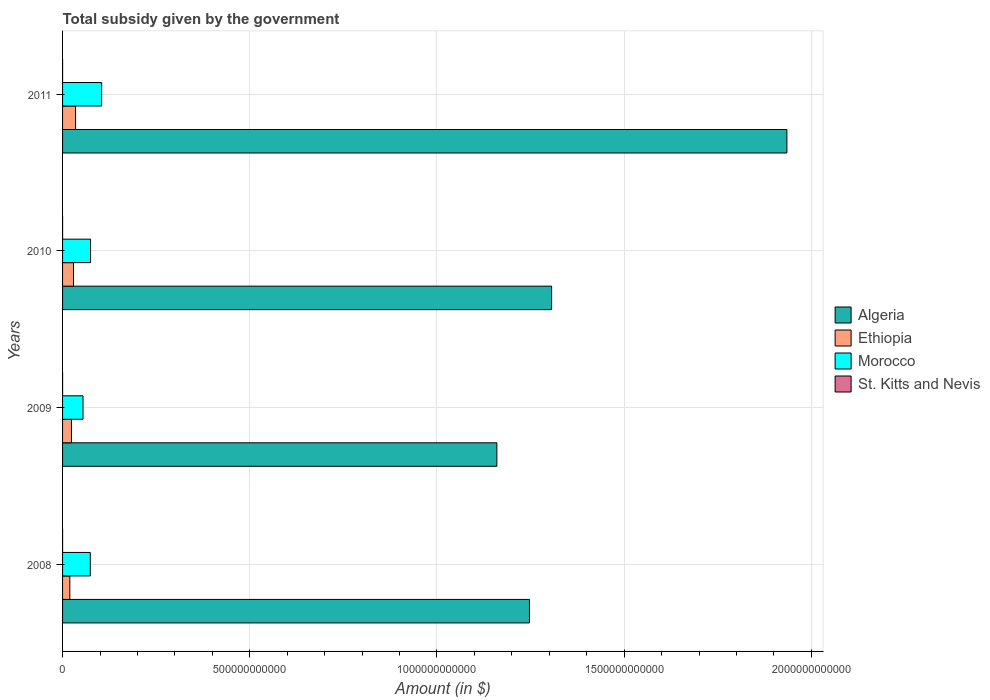How many bars are there on the 2nd tick from the top?
Offer a very short reply. 4. How many bars are there on the 2nd tick from the bottom?
Ensure brevity in your answer.  4. What is the label of the 3rd group of bars from the top?
Ensure brevity in your answer.  2009. In how many cases, is the number of bars for a given year not equal to the number of legend labels?
Make the answer very short. 0. What is the total revenue collected by the government in Ethiopia in 2009?
Keep it short and to the point. 2.37e+1. Across all years, what is the maximum total revenue collected by the government in St. Kitts and Nevis?
Your answer should be compact. 7.11e+07. Across all years, what is the minimum total revenue collected by the government in Algeria?
Give a very brief answer. 1.16e+12. In which year was the total revenue collected by the government in St. Kitts and Nevis minimum?
Your answer should be compact. 2010. What is the total total revenue collected by the government in St. Kitts and Nevis in the graph?
Keep it short and to the point. 2.46e+08. What is the difference between the total revenue collected by the government in St. Kitts and Nevis in 2008 and that in 2011?
Give a very brief answer. -1.25e+07. What is the difference between the total revenue collected by the government in Morocco in 2010 and the total revenue collected by the government in St. Kitts and Nevis in 2011?
Your answer should be very brief. 7.48e+1. What is the average total revenue collected by the government in St. Kitts and Nevis per year?
Offer a terse response. 6.16e+07. In the year 2008, what is the difference between the total revenue collected by the government in Morocco and total revenue collected by the government in Algeria?
Provide a succinct answer. -1.17e+12. In how many years, is the total revenue collected by the government in St. Kitts and Nevis greater than 500000000000 $?
Your answer should be compact. 0. What is the ratio of the total revenue collected by the government in St. Kitts and Nevis in 2009 to that in 2010?
Offer a very short reply. 1.03. Is the total revenue collected by the government in St. Kitts and Nevis in 2008 less than that in 2010?
Your answer should be compact. No. What is the difference between the highest and the second highest total revenue collected by the government in St. Kitts and Nevis?
Your answer should be very brief. 1.20e+07. What is the difference between the highest and the lowest total revenue collected by the government in Ethiopia?
Give a very brief answer. 1.53e+1. What does the 2nd bar from the top in 2010 represents?
Your response must be concise. Morocco. What does the 2nd bar from the bottom in 2010 represents?
Ensure brevity in your answer.  Ethiopia. Is it the case that in every year, the sum of the total revenue collected by the government in St. Kitts and Nevis and total revenue collected by the government in Algeria is greater than the total revenue collected by the government in Ethiopia?
Offer a terse response. Yes. How many years are there in the graph?
Offer a terse response. 4. What is the difference between two consecutive major ticks on the X-axis?
Your response must be concise. 5.00e+11. Are the values on the major ticks of X-axis written in scientific E-notation?
Your response must be concise. No. Does the graph contain any zero values?
Make the answer very short. No. How are the legend labels stacked?
Your answer should be very brief. Vertical. What is the title of the graph?
Your answer should be very brief. Total subsidy given by the government. Does "Vietnam" appear as one of the legend labels in the graph?
Ensure brevity in your answer.  No. What is the label or title of the X-axis?
Offer a terse response. Amount (in $). What is the label or title of the Y-axis?
Keep it short and to the point. Years. What is the Amount (in $) in Algeria in 2008?
Ensure brevity in your answer.  1.25e+12. What is the Amount (in $) of Ethiopia in 2008?
Your response must be concise. 1.94e+1. What is the Amount (in $) of Morocco in 2008?
Your response must be concise. 7.41e+1. What is the Amount (in $) of St. Kitts and Nevis in 2008?
Offer a terse response. 5.86e+07. What is the Amount (in $) of Algeria in 2009?
Your answer should be compact. 1.16e+12. What is the Amount (in $) in Ethiopia in 2009?
Offer a very short reply. 2.37e+1. What is the Amount (in $) of Morocco in 2009?
Provide a succinct answer. 5.46e+1. What is the Amount (in $) in St. Kitts and Nevis in 2009?
Your response must be concise. 5.91e+07. What is the Amount (in $) of Algeria in 2010?
Provide a short and direct response. 1.31e+12. What is the Amount (in $) in Ethiopia in 2010?
Your response must be concise. 2.92e+1. What is the Amount (in $) of Morocco in 2010?
Ensure brevity in your answer.  7.48e+1. What is the Amount (in $) of St. Kitts and Nevis in 2010?
Provide a succinct answer. 5.76e+07. What is the Amount (in $) of Algeria in 2011?
Provide a succinct answer. 1.93e+12. What is the Amount (in $) in Ethiopia in 2011?
Provide a succinct answer. 3.47e+1. What is the Amount (in $) of Morocco in 2011?
Your answer should be very brief. 1.04e+11. What is the Amount (in $) in St. Kitts and Nevis in 2011?
Your answer should be compact. 7.11e+07. Across all years, what is the maximum Amount (in $) in Algeria?
Offer a very short reply. 1.93e+12. Across all years, what is the maximum Amount (in $) in Ethiopia?
Offer a very short reply. 3.47e+1. Across all years, what is the maximum Amount (in $) in Morocco?
Offer a very short reply. 1.04e+11. Across all years, what is the maximum Amount (in $) of St. Kitts and Nevis?
Offer a very short reply. 7.11e+07. Across all years, what is the minimum Amount (in $) of Algeria?
Offer a terse response. 1.16e+12. Across all years, what is the minimum Amount (in $) of Ethiopia?
Give a very brief answer. 1.94e+1. Across all years, what is the minimum Amount (in $) in Morocco?
Provide a succinct answer. 5.46e+1. Across all years, what is the minimum Amount (in $) of St. Kitts and Nevis?
Your answer should be very brief. 5.76e+07. What is the total Amount (in $) in Algeria in the graph?
Make the answer very short. 5.65e+12. What is the total Amount (in $) of Ethiopia in the graph?
Keep it short and to the point. 1.07e+11. What is the total Amount (in $) in Morocco in the graph?
Make the answer very short. 3.08e+11. What is the total Amount (in $) of St. Kitts and Nevis in the graph?
Give a very brief answer. 2.46e+08. What is the difference between the Amount (in $) of Algeria in 2008 and that in 2009?
Make the answer very short. 8.71e+1. What is the difference between the Amount (in $) of Ethiopia in 2008 and that in 2009?
Your answer should be very brief. -4.33e+09. What is the difference between the Amount (in $) of Morocco in 2008 and that in 2009?
Offer a very short reply. 1.95e+1. What is the difference between the Amount (in $) of St. Kitts and Nevis in 2008 and that in 2009?
Offer a very short reply. -5.00e+05. What is the difference between the Amount (in $) in Algeria in 2008 and that in 2010?
Your response must be concise. -5.92e+1. What is the difference between the Amount (in $) of Ethiopia in 2008 and that in 2010?
Give a very brief answer. -9.79e+09. What is the difference between the Amount (in $) of Morocco in 2008 and that in 2010?
Make the answer very short. -7.28e+08. What is the difference between the Amount (in $) of St. Kitts and Nevis in 2008 and that in 2010?
Offer a terse response. 1.00e+06. What is the difference between the Amount (in $) in Algeria in 2008 and that in 2011?
Offer a terse response. -6.88e+11. What is the difference between the Amount (in $) in Ethiopia in 2008 and that in 2011?
Keep it short and to the point. -1.53e+1. What is the difference between the Amount (in $) in Morocco in 2008 and that in 2011?
Keep it short and to the point. -3.03e+1. What is the difference between the Amount (in $) in St. Kitts and Nevis in 2008 and that in 2011?
Your answer should be compact. -1.25e+07. What is the difference between the Amount (in $) in Algeria in 2009 and that in 2010?
Your response must be concise. -1.46e+11. What is the difference between the Amount (in $) in Ethiopia in 2009 and that in 2010?
Give a very brief answer. -5.47e+09. What is the difference between the Amount (in $) in Morocco in 2009 and that in 2010?
Your answer should be compact. -2.02e+1. What is the difference between the Amount (in $) in St. Kitts and Nevis in 2009 and that in 2010?
Offer a very short reply. 1.50e+06. What is the difference between the Amount (in $) in Algeria in 2009 and that in 2011?
Provide a short and direct response. -7.75e+11. What is the difference between the Amount (in $) of Ethiopia in 2009 and that in 2011?
Your answer should be compact. -1.10e+1. What is the difference between the Amount (in $) in Morocco in 2009 and that in 2011?
Your answer should be compact. -4.98e+1. What is the difference between the Amount (in $) in St. Kitts and Nevis in 2009 and that in 2011?
Your answer should be very brief. -1.20e+07. What is the difference between the Amount (in $) of Algeria in 2010 and that in 2011?
Offer a very short reply. -6.28e+11. What is the difference between the Amount (in $) in Ethiopia in 2010 and that in 2011?
Offer a very short reply. -5.52e+09. What is the difference between the Amount (in $) of Morocco in 2010 and that in 2011?
Your answer should be very brief. -2.96e+1. What is the difference between the Amount (in $) of St. Kitts and Nevis in 2010 and that in 2011?
Your response must be concise. -1.35e+07. What is the difference between the Amount (in $) in Algeria in 2008 and the Amount (in $) in Ethiopia in 2009?
Your answer should be compact. 1.22e+12. What is the difference between the Amount (in $) in Algeria in 2008 and the Amount (in $) in Morocco in 2009?
Ensure brevity in your answer.  1.19e+12. What is the difference between the Amount (in $) in Algeria in 2008 and the Amount (in $) in St. Kitts and Nevis in 2009?
Offer a terse response. 1.25e+12. What is the difference between the Amount (in $) of Ethiopia in 2008 and the Amount (in $) of Morocco in 2009?
Offer a terse response. -3.52e+1. What is the difference between the Amount (in $) of Ethiopia in 2008 and the Amount (in $) of St. Kitts and Nevis in 2009?
Offer a terse response. 1.93e+1. What is the difference between the Amount (in $) in Morocco in 2008 and the Amount (in $) in St. Kitts and Nevis in 2009?
Your answer should be compact. 7.41e+1. What is the difference between the Amount (in $) in Algeria in 2008 and the Amount (in $) in Ethiopia in 2010?
Keep it short and to the point. 1.22e+12. What is the difference between the Amount (in $) in Algeria in 2008 and the Amount (in $) in Morocco in 2010?
Make the answer very short. 1.17e+12. What is the difference between the Amount (in $) of Algeria in 2008 and the Amount (in $) of St. Kitts and Nevis in 2010?
Offer a terse response. 1.25e+12. What is the difference between the Amount (in $) of Ethiopia in 2008 and the Amount (in $) of Morocco in 2010?
Give a very brief answer. -5.54e+1. What is the difference between the Amount (in $) in Ethiopia in 2008 and the Amount (in $) in St. Kitts and Nevis in 2010?
Offer a very short reply. 1.93e+1. What is the difference between the Amount (in $) of Morocco in 2008 and the Amount (in $) of St. Kitts and Nevis in 2010?
Your response must be concise. 7.41e+1. What is the difference between the Amount (in $) in Algeria in 2008 and the Amount (in $) in Ethiopia in 2011?
Keep it short and to the point. 1.21e+12. What is the difference between the Amount (in $) in Algeria in 2008 and the Amount (in $) in Morocco in 2011?
Ensure brevity in your answer.  1.14e+12. What is the difference between the Amount (in $) of Algeria in 2008 and the Amount (in $) of St. Kitts and Nevis in 2011?
Keep it short and to the point. 1.25e+12. What is the difference between the Amount (in $) in Ethiopia in 2008 and the Amount (in $) in Morocco in 2011?
Offer a terse response. -8.51e+1. What is the difference between the Amount (in $) of Ethiopia in 2008 and the Amount (in $) of St. Kitts and Nevis in 2011?
Keep it short and to the point. 1.93e+1. What is the difference between the Amount (in $) in Morocco in 2008 and the Amount (in $) in St. Kitts and Nevis in 2011?
Provide a short and direct response. 7.40e+1. What is the difference between the Amount (in $) in Algeria in 2009 and the Amount (in $) in Ethiopia in 2010?
Your response must be concise. 1.13e+12. What is the difference between the Amount (in $) of Algeria in 2009 and the Amount (in $) of Morocco in 2010?
Keep it short and to the point. 1.09e+12. What is the difference between the Amount (in $) of Algeria in 2009 and the Amount (in $) of St. Kitts and Nevis in 2010?
Provide a succinct answer. 1.16e+12. What is the difference between the Amount (in $) of Ethiopia in 2009 and the Amount (in $) of Morocco in 2010?
Give a very brief answer. -5.11e+1. What is the difference between the Amount (in $) in Ethiopia in 2009 and the Amount (in $) in St. Kitts and Nevis in 2010?
Give a very brief answer. 2.37e+1. What is the difference between the Amount (in $) in Morocco in 2009 and the Amount (in $) in St. Kitts and Nevis in 2010?
Your answer should be compact. 5.46e+1. What is the difference between the Amount (in $) in Algeria in 2009 and the Amount (in $) in Ethiopia in 2011?
Your answer should be very brief. 1.13e+12. What is the difference between the Amount (in $) of Algeria in 2009 and the Amount (in $) of Morocco in 2011?
Offer a terse response. 1.06e+12. What is the difference between the Amount (in $) of Algeria in 2009 and the Amount (in $) of St. Kitts and Nevis in 2011?
Offer a very short reply. 1.16e+12. What is the difference between the Amount (in $) in Ethiopia in 2009 and the Amount (in $) in Morocco in 2011?
Keep it short and to the point. -8.07e+1. What is the difference between the Amount (in $) in Ethiopia in 2009 and the Amount (in $) in St. Kitts and Nevis in 2011?
Make the answer very short. 2.37e+1. What is the difference between the Amount (in $) of Morocco in 2009 and the Amount (in $) of St. Kitts and Nevis in 2011?
Keep it short and to the point. 5.45e+1. What is the difference between the Amount (in $) in Algeria in 2010 and the Amount (in $) in Ethiopia in 2011?
Your answer should be very brief. 1.27e+12. What is the difference between the Amount (in $) of Algeria in 2010 and the Amount (in $) of Morocco in 2011?
Your answer should be compact. 1.20e+12. What is the difference between the Amount (in $) in Algeria in 2010 and the Amount (in $) in St. Kitts and Nevis in 2011?
Provide a short and direct response. 1.31e+12. What is the difference between the Amount (in $) of Ethiopia in 2010 and the Amount (in $) of Morocco in 2011?
Keep it short and to the point. -7.53e+1. What is the difference between the Amount (in $) of Ethiopia in 2010 and the Amount (in $) of St. Kitts and Nevis in 2011?
Your response must be concise. 2.91e+1. What is the difference between the Amount (in $) in Morocco in 2010 and the Amount (in $) in St. Kitts and Nevis in 2011?
Keep it short and to the point. 7.48e+1. What is the average Amount (in $) of Algeria per year?
Keep it short and to the point. 1.41e+12. What is the average Amount (in $) in Ethiopia per year?
Give a very brief answer. 2.68e+1. What is the average Amount (in $) in Morocco per year?
Offer a terse response. 7.70e+1. What is the average Amount (in $) of St. Kitts and Nevis per year?
Make the answer very short. 6.16e+07. In the year 2008, what is the difference between the Amount (in $) in Algeria and Amount (in $) in Ethiopia?
Keep it short and to the point. 1.23e+12. In the year 2008, what is the difference between the Amount (in $) in Algeria and Amount (in $) in Morocco?
Your answer should be compact. 1.17e+12. In the year 2008, what is the difference between the Amount (in $) of Algeria and Amount (in $) of St. Kitts and Nevis?
Provide a short and direct response. 1.25e+12. In the year 2008, what is the difference between the Amount (in $) of Ethiopia and Amount (in $) of Morocco?
Your answer should be very brief. -5.47e+1. In the year 2008, what is the difference between the Amount (in $) in Ethiopia and Amount (in $) in St. Kitts and Nevis?
Ensure brevity in your answer.  1.93e+1. In the year 2008, what is the difference between the Amount (in $) in Morocco and Amount (in $) in St. Kitts and Nevis?
Your answer should be very brief. 7.41e+1. In the year 2009, what is the difference between the Amount (in $) of Algeria and Amount (in $) of Ethiopia?
Make the answer very short. 1.14e+12. In the year 2009, what is the difference between the Amount (in $) of Algeria and Amount (in $) of Morocco?
Provide a succinct answer. 1.11e+12. In the year 2009, what is the difference between the Amount (in $) in Algeria and Amount (in $) in St. Kitts and Nevis?
Give a very brief answer. 1.16e+12. In the year 2009, what is the difference between the Amount (in $) of Ethiopia and Amount (in $) of Morocco?
Offer a very short reply. -3.09e+1. In the year 2009, what is the difference between the Amount (in $) in Ethiopia and Amount (in $) in St. Kitts and Nevis?
Offer a very short reply. 2.37e+1. In the year 2009, what is the difference between the Amount (in $) of Morocco and Amount (in $) of St. Kitts and Nevis?
Give a very brief answer. 5.46e+1. In the year 2010, what is the difference between the Amount (in $) of Algeria and Amount (in $) of Ethiopia?
Your answer should be compact. 1.28e+12. In the year 2010, what is the difference between the Amount (in $) of Algeria and Amount (in $) of Morocco?
Your answer should be compact. 1.23e+12. In the year 2010, what is the difference between the Amount (in $) in Algeria and Amount (in $) in St. Kitts and Nevis?
Provide a succinct answer. 1.31e+12. In the year 2010, what is the difference between the Amount (in $) in Ethiopia and Amount (in $) in Morocco?
Your response must be concise. -4.57e+1. In the year 2010, what is the difference between the Amount (in $) in Ethiopia and Amount (in $) in St. Kitts and Nevis?
Make the answer very short. 2.91e+1. In the year 2010, what is the difference between the Amount (in $) in Morocco and Amount (in $) in St. Kitts and Nevis?
Your response must be concise. 7.48e+1. In the year 2011, what is the difference between the Amount (in $) in Algeria and Amount (in $) in Ethiopia?
Offer a terse response. 1.90e+12. In the year 2011, what is the difference between the Amount (in $) of Algeria and Amount (in $) of Morocco?
Provide a succinct answer. 1.83e+12. In the year 2011, what is the difference between the Amount (in $) of Algeria and Amount (in $) of St. Kitts and Nevis?
Your response must be concise. 1.93e+12. In the year 2011, what is the difference between the Amount (in $) in Ethiopia and Amount (in $) in Morocco?
Provide a short and direct response. -6.97e+1. In the year 2011, what is the difference between the Amount (in $) of Ethiopia and Amount (in $) of St. Kitts and Nevis?
Give a very brief answer. 3.46e+1. In the year 2011, what is the difference between the Amount (in $) in Morocco and Amount (in $) in St. Kitts and Nevis?
Keep it short and to the point. 1.04e+11. What is the ratio of the Amount (in $) of Algeria in 2008 to that in 2009?
Offer a very short reply. 1.08. What is the ratio of the Amount (in $) in Ethiopia in 2008 to that in 2009?
Keep it short and to the point. 0.82. What is the ratio of the Amount (in $) of Morocco in 2008 to that in 2009?
Provide a short and direct response. 1.36. What is the ratio of the Amount (in $) in St. Kitts and Nevis in 2008 to that in 2009?
Provide a succinct answer. 0.99. What is the ratio of the Amount (in $) in Algeria in 2008 to that in 2010?
Offer a very short reply. 0.95. What is the ratio of the Amount (in $) in Ethiopia in 2008 to that in 2010?
Your response must be concise. 0.66. What is the ratio of the Amount (in $) of Morocco in 2008 to that in 2010?
Provide a short and direct response. 0.99. What is the ratio of the Amount (in $) in St. Kitts and Nevis in 2008 to that in 2010?
Provide a short and direct response. 1.02. What is the ratio of the Amount (in $) in Algeria in 2008 to that in 2011?
Your answer should be compact. 0.64. What is the ratio of the Amount (in $) of Ethiopia in 2008 to that in 2011?
Offer a terse response. 0.56. What is the ratio of the Amount (in $) of Morocco in 2008 to that in 2011?
Ensure brevity in your answer.  0.71. What is the ratio of the Amount (in $) in St. Kitts and Nevis in 2008 to that in 2011?
Offer a terse response. 0.82. What is the ratio of the Amount (in $) in Algeria in 2009 to that in 2010?
Ensure brevity in your answer.  0.89. What is the ratio of the Amount (in $) of Ethiopia in 2009 to that in 2010?
Offer a terse response. 0.81. What is the ratio of the Amount (in $) of Morocco in 2009 to that in 2010?
Your answer should be very brief. 0.73. What is the ratio of the Amount (in $) of Algeria in 2009 to that in 2011?
Provide a succinct answer. 0.6. What is the ratio of the Amount (in $) in Ethiopia in 2009 to that in 2011?
Your response must be concise. 0.68. What is the ratio of the Amount (in $) in Morocco in 2009 to that in 2011?
Your response must be concise. 0.52. What is the ratio of the Amount (in $) of St. Kitts and Nevis in 2009 to that in 2011?
Your answer should be very brief. 0.83. What is the ratio of the Amount (in $) of Algeria in 2010 to that in 2011?
Make the answer very short. 0.68. What is the ratio of the Amount (in $) in Ethiopia in 2010 to that in 2011?
Give a very brief answer. 0.84. What is the ratio of the Amount (in $) of Morocco in 2010 to that in 2011?
Provide a short and direct response. 0.72. What is the ratio of the Amount (in $) of St. Kitts and Nevis in 2010 to that in 2011?
Your answer should be compact. 0.81. What is the difference between the highest and the second highest Amount (in $) of Algeria?
Offer a terse response. 6.28e+11. What is the difference between the highest and the second highest Amount (in $) of Ethiopia?
Ensure brevity in your answer.  5.52e+09. What is the difference between the highest and the second highest Amount (in $) of Morocco?
Make the answer very short. 2.96e+1. What is the difference between the highest and the lowest Amount (in $) in Algeria?
Keep it short and to the point. 7.75e+11. What is the difference between the highest and the lowest Amount (in $) of Ethiopia?
Give a very brief answer. 1.53e+1. What is the difference between the highest and the lowest Amount (in $) of Morocco?
Provide a short and direct response. 4.98e+1. What is the difference between the highest and the lowest Amount (in $) in St. Kitts and Nevis?
Keep it short and to the point. 1.35e+07. 